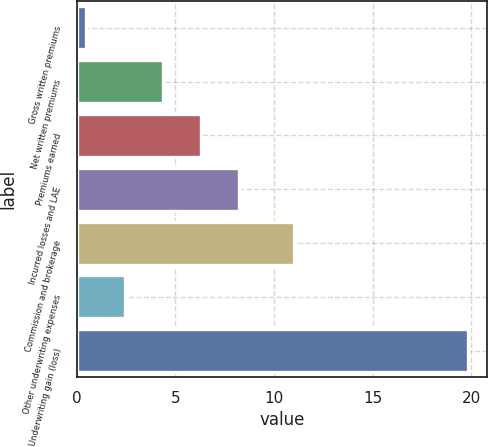Convert chart. <chart><loc_0><loc_0><loc_500><loc_500><bar_chart><fcel>Gross written premiums<fcel>Net written premiums<fcel>Premiums earned<fcel>Incurred losses and LAE<fcel>Commission and brokerage<fcel>Other underwriting expenses<fcel>Underwriting gain (loss)<nl><fcel>0.5<fcel>4.36<fcel>6.29<fcel>8.22<fcel>11<fcel>2.43<fcel>19.8<nl></chart> 